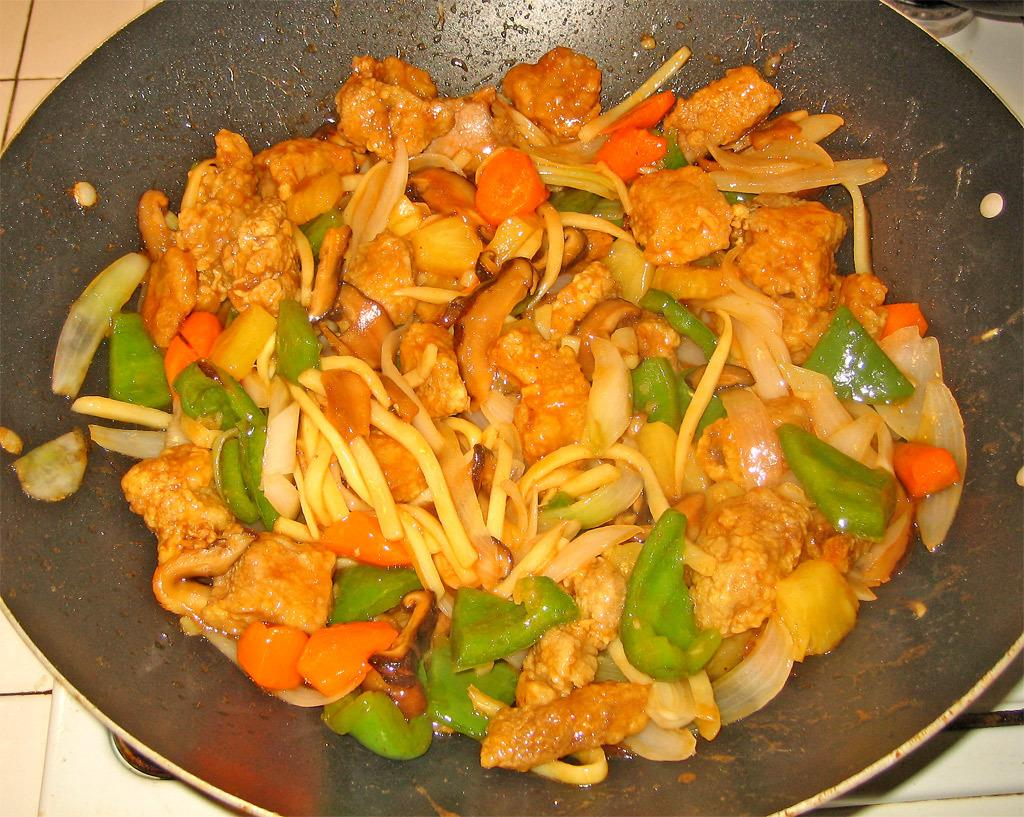What is: What is inside the container that is visible in the image? There is a container with food items in the image. Where is the container located in the image? The container is placed on a surface in the image. Are there any pets visible in the image? There is no mention of pets in the provided facts, so we cannot determine if any are present in the image. 